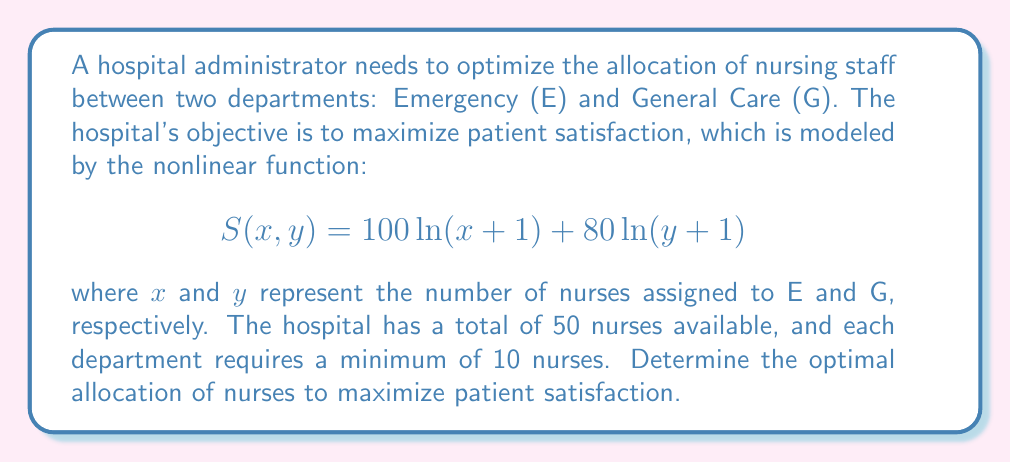What is the answer to this math problem? To solve this nonlinear programming problem, we'll follow these steps:

1) Define the objective function and constraints:
   Maximize: $S(x, y) = 100\ln(x+1) + 80\ln(y+1)$
   Subject to: $x + y \leq 50$ (total nurses)
               $x \geq 10$, $y \geq 10$ (minimum requirements)
               $x, y \geq 0$ (non-negativity)

2) This is a constrained optimization problem. We can use the method of Lagrange multipliers:
   $L(x, y, \lambda) = 100\ln(x+1) + 80\ln(y+1) - \lambda(x + y - 50)$

3) Find partial derivatives and set them to zero:
   $\frac{\partial L}{\partial x} = \frac{100}{x+1} - \lambda = 0$
   $\frac{\partial L}{\partial y} = \frac{80}{y+1} - \lambda = 0$
   $\frac{\partial L}{\partial \lambda} = x + y - 50 = 0$

4) From the first two equations:
   $\frac{100}{x+1} = \frac{80}{y+1}$

5) Cross-multiply:
   $100(y+1) = 80(x+1)$
   $100y + 100 = 80x + 80$
   $100y - 80x = -20$
   $5y - 4x = -1$

6) Substitute this into $x + y = 50$:
   $x + \frac{4x+1}{5} = 50$
   $5x + 4x + 1 = 250$
   $9x = 249$
   $x = 27.67$

7) Substitute back to find y:
   $y = 50 - 27.67 = 22.33$

8) Round to nearest whole number (as we can't have fractional nurses):
   $x = 28$, $y = 22$

9) Check constraints:
   $28 + 22 = 50$ (total nurses constraint satisfied)
   $28 \geq 10$, $22 \geq 10$ (minimum requirements satisfied)

Therefore, the optimal allocation is 28 nurses to Emergency and 22 nurses to General Care.
Answer: 28 nurses to Emergency, 22 nurses to General Care 